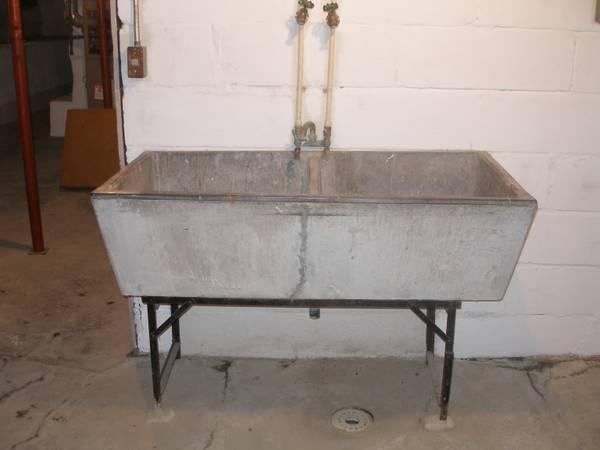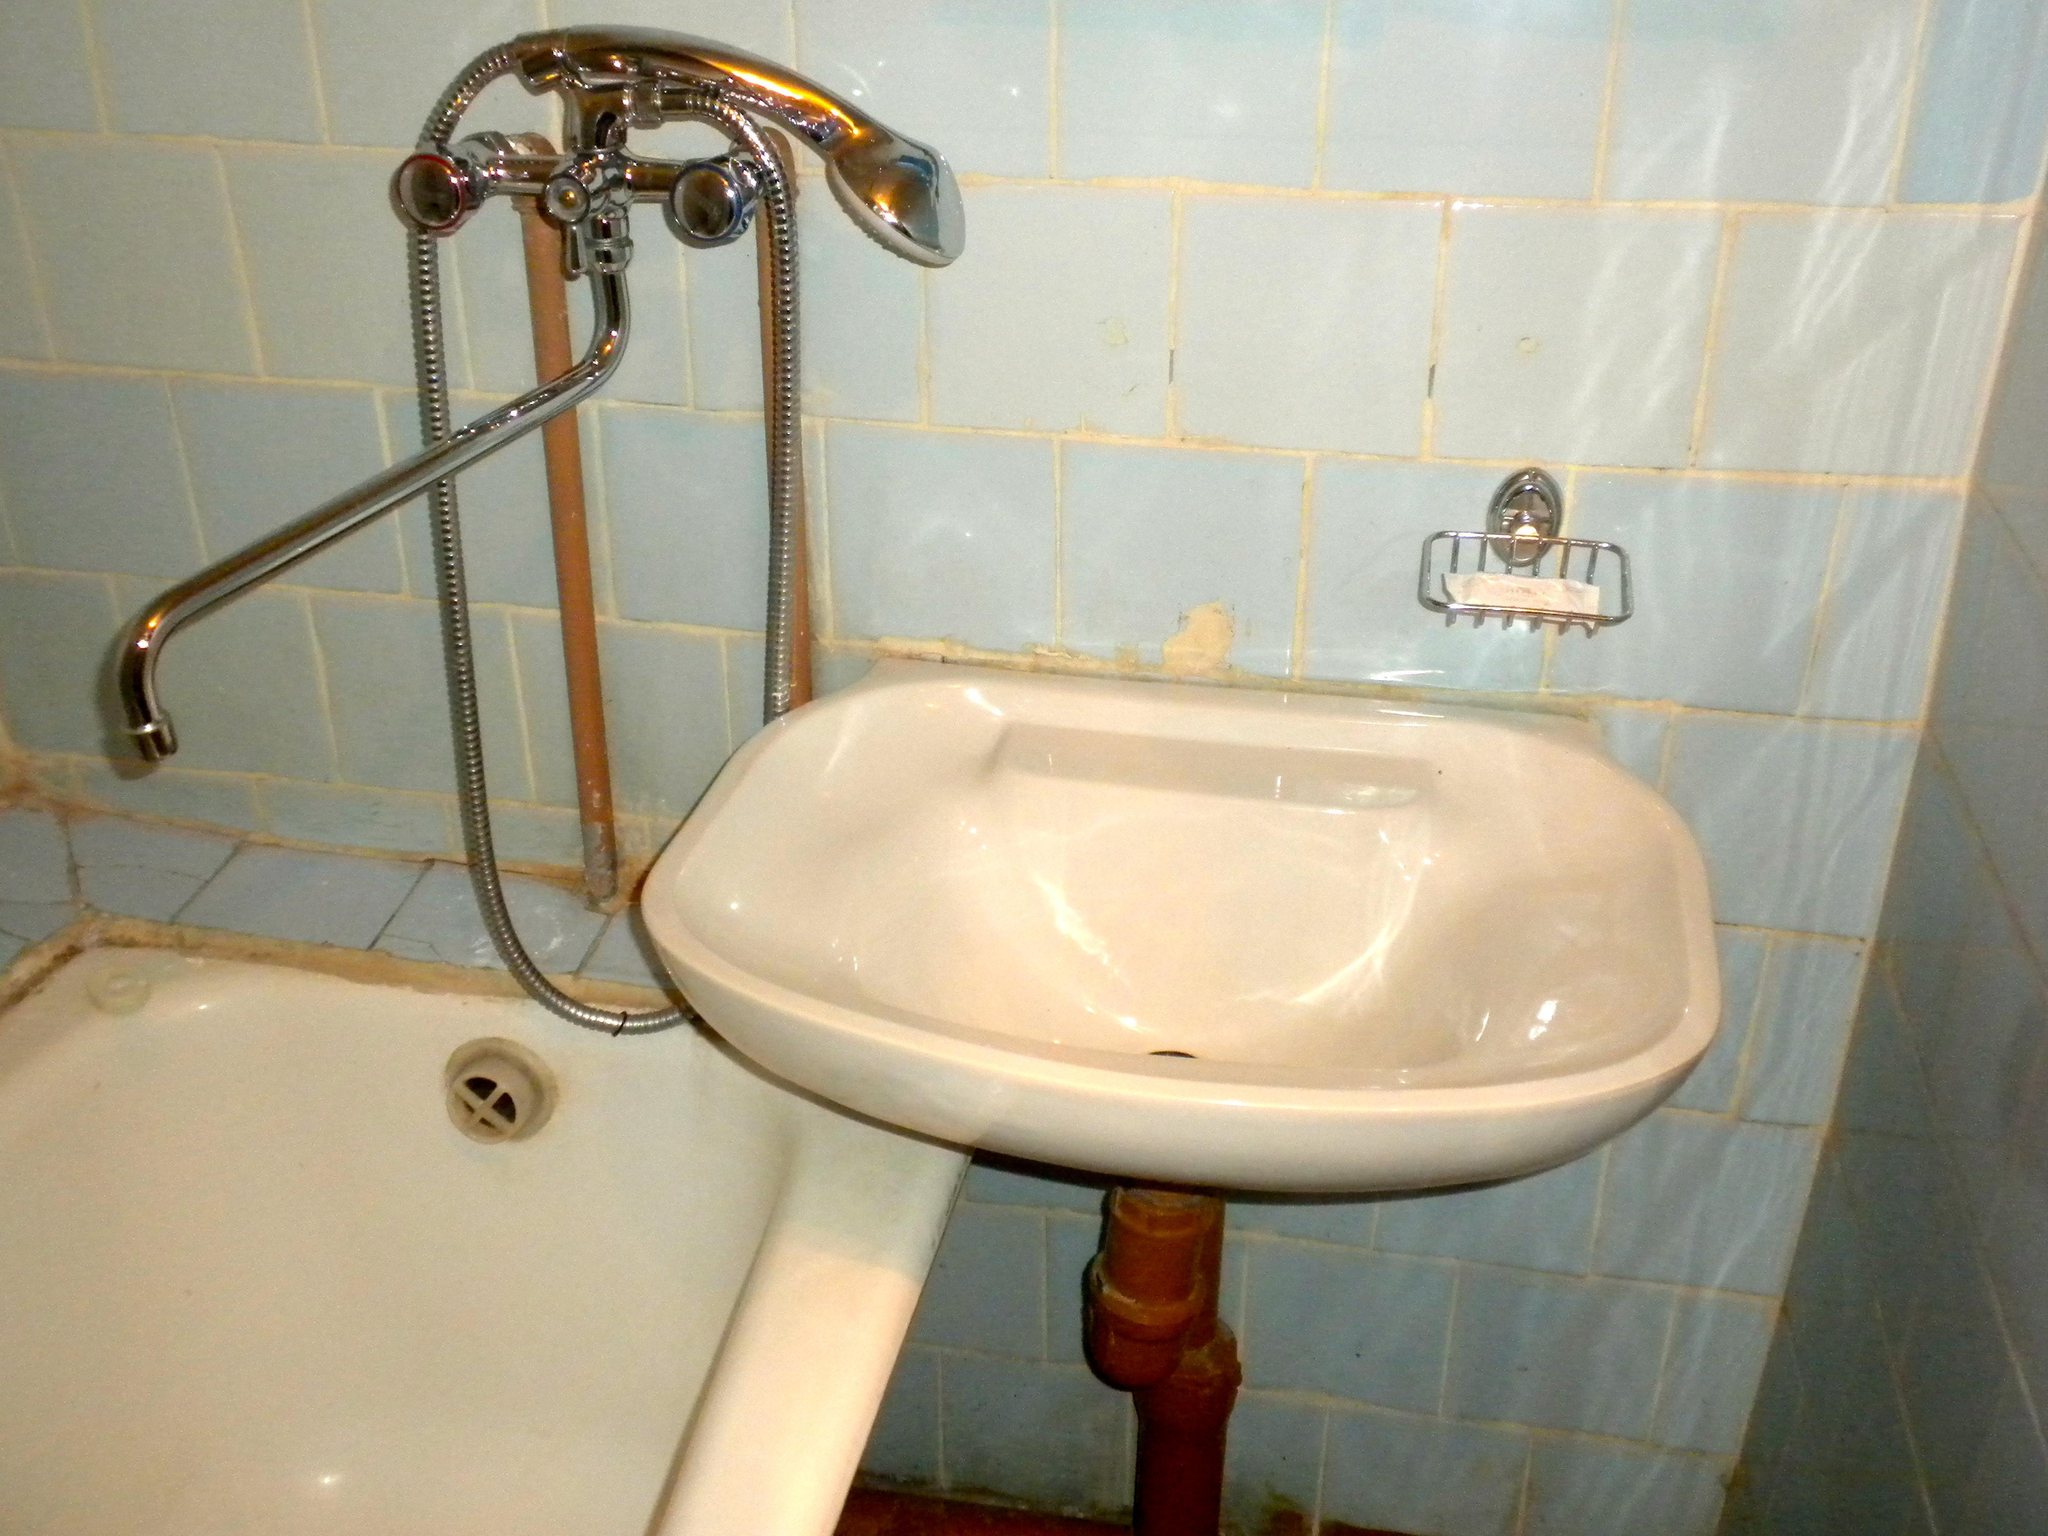The first image is the image on the left, the second image is the image on the right. Examine the images to the left and right. Is the description "The counter in the image on the right is white on a black cabinet." accurate? Answer yes or no. No. 